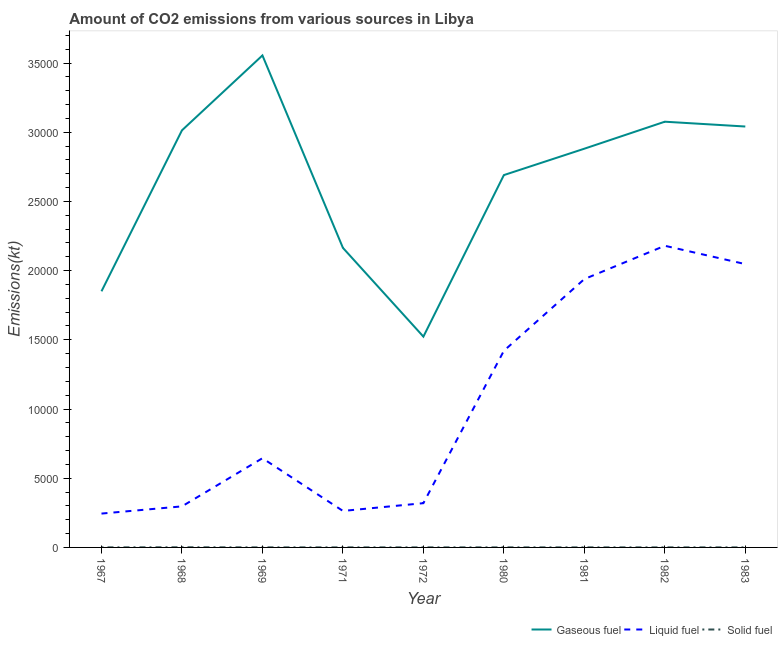How many different coloured lines are there?
Your answer should be compact. 3. Is the number of lines equal to the number of legend labels?
Keep it short and to the point. Yes. What is the amount of co2 emissions from solid fuel in 1967?
Your answer should be very brief. 3.67. Across all years, what is the maximum amount of co2 emissions from gaseous fuel?
Ensure brevity in your answer.  3.56e+04. Across all years, what is the minimum amount of co2 emissions from gaseous fuel?
Your response must be concise. 1.52e+04. In which year was the amount of co2 emissions from solid fuel maximum?
Give a very brief answer. 1968. In which year was the amount of co2 emissions from gaseous fuel minimum?
Offer a terse response. 1972. What is the total amount of co2 emissions from liquid fuel in the graph?
Your answer should be very brief. 9.36e+04. What is the difference between the amount of co2 emissions from solid fuel in 1969 and that in 1983?
Your answer should be compact. 0. What is the difference between the amount of co2 emissions from solid fuel in 1981 and the amount of co2 emissions from gaseous fuel in 1967?
Make the answer very short. -1.85e+04. What is the average amount of co2 emissions from solid fuel per year?
Give a very brief answer. 4.48. In the year 1983, what is the difference between the amount of co2 emissions from gaseous fuel and amount of co2 emissions from solid fuel?
Keep it short and to the point. 3.04e+04. What is the ratio of the amount of co2 emissions from liquid fuel in 1967 to that in 1968?
Your answer should be compact. 0.82. Is the amount of co2 emissions from gaseous fuel in 1968 less than that in 1971?
Your answer should be compact. No. Is the difference between the amount of co2 emissions from solid fuel in 1969 and 1980 greater than the difference between the amount of co2 emissions from liquid fuel in 1969 and 1980?
Keep it short and to the point. Yes. What is the difference between the highest and the second highest amount of co2 emissions from gaseous fuel?
Give a very brief answer. 4789.1. What is the difference between the highest and the lowest amount of co2 emissions from solid fuel?
Your answer should be compact. 7.33. In how many years, is the amount of co2 emissions from liquid fuel greater than the average amount of co2 emissions from liquid fuel taken over all years?
Your response must be concise. 4. Is the sum of the amount of co2 emissions from solid fuel in 1982 and 1983 greater than the maximum amount of co2 emissions from liquid fuel across all years?
Offer a very short reply. No. Is the amount of co2 emissions from gaseous fuel strictly less than the amount of co2 emissions from liquid fuel over the years?
Provide a short and direct response. No. How many years are there in the graph?
Your answer should be compact. 9. What is the difference between two consecutive major ticks on the Y-axis?
Offer a terse response. 5000. Are the values on the major ticks of Y-axis written in scientific E-notation?
Keep it short and to the point. No. Does the graph contain any zero values?
Your answer should be compact. No. Does the graph contain grids?
Make the answer very short. No. How many legend labels are there?
Offer a terse response. 3. What is the title of the graph?
Ensure brevity in your answer.  Amount of CO2 emissions from various sources in Libya. What is the label or title of the X-axis?
Your response must be concise. Year. What is the label or title of the Y-axis?
Your response must be concise. Emissions(kt). What is the Emissions(kt) of Gaseous fuel in 1967?
Offer a very short reply. 1.85e+04. What is the Emissions(kt) in Liquid fuel in 1967?
Provide a short and direct response. 2445.89. What is the Emissions(kt) in Solid fuel in 1967?
Give a very brief answer. 3.67. What is the Emissions(kt) of Gaseous fuel in 1968?
Keep it short and to the point. 3.01e+04. What is the Emissions(kt) in Liquid fuel in 1968?
Ensure brevity in your answer.  2966.6. What is the Emissions(kt) in Solid fuel in 1968?
Offer a terse response. 11. What is the Emissions(kt) of Gaseous fuel in 1969?
Provide a succinct answer. 3.56e+04. What is the Emissions(kt) in Liquid fuel in 1969?
Offer a terse response. 6446.59. What is the Emissions(kt) of Solid fuel in 1969?
Provide a succinct answer. 3.67. What is the Emissions(kt) in Gaseous fuel in 1971?
Your answer should be very brief. 2.16e+04. What is the Emissions(kt) in Liquid fuel in 1971?
Your answer should be very brief. 2636.57. What is the Emissions(kt) of Solid fuel in 1971?
Offer a terse response. 3.67. What is the Emissions(kt) of Gaseous fuel in 1972?
Make the answer very short. 1.52e+04. What is the Emissions(kt) in Liquid fuel in 1972?
Ensure brevity in your answer.  3197.62. What is the Emissions(kt) of Solid fuel in 1972?
Ensure brevity in your answer.  3.67. What is the Emissions(kt) of Gaseous fuel in 1980?
Ensure brevity in your answer.  2.69e+04. What is the Emissions(kt) of Liquid fuel in 1980?
Offer a terse response. 1.42e+04. What is the Emissions(kt) of Solid fuel in 1980?
Ensure brevity in your answer.  3.67. What is the Emissions(kt) in Gaseous fuel in 1981?
Provide a short and direct response. 2.88e+04. What is the Emissions(kt) in Liquid fuel in 1981?
Make the answer very short. 1.94e+04. What is the Emissions(kt) of Solid fuel in 1981?
Keep it short and to the point. 3.67. What is the Emissions(kt) in Gaseous fuel in 1982?
Offer a terse response. 3.08e+04. What is the Emissions(kt) in Liquid fuel in 1982?
Provide a succinct answer. 2.18e+04. What is the Emissions(kt) of Solid fuel in 1982?
Give a very brief answer. 3.67. What is the Emissions(kt) in Gaseous fuel in 1983?
Provide a succinct answer. 3.04e+04. What is the Emissions(kt) in Liquid fuel in 1983?
Offer a very short reply. 2.05e+04. What is the Emissions(kt) in Solid fuel in 1983?
Your answer should be compact. 3.67. Across all years, what is the maximum Emissions(kt) of Gaseous fuel?
Ensure brevity in your answer.  3.56e+04. Across all years, what is the maximum Emissions(kt) in Liquid fuel?
Provide a succinct answer. 2.18e+04. Across all years, what is the maximum Emissions(kt) of Solid fuel?
Your answer should be compact. 11. Across all years, what is the minimum Emissions(kt) of Gaseous fuel?
Keep it short and to the point. 1.52e+04. Across all years, what is the minimum Emissions(kt) of Liquid fuel?
Give a very brief answer. 2445.89. Across all years, what is the minimum Emissions(kt) in Solid fuel?
Your answer should be very brief. 3.67. What is the total Emissions(kt) of Gaseous fuel in the graph?
Give a very brief answer. 2.38e+05. What is the total Emissions(kt) in Liquid fuel in the graph?
Give a very brief answer. 9.36e+04. What is the total Emissions(kt) in Solid fuel in the graph?
Give a very brief answer. 40.34. What is the difference between the Emissions(kt) of Gaseous fuel in 1967 and that in 1968?
Your answer should be very brief. -1.16e+04. What is the difference between the Emissions(kt) of Liquid fuel in 1967 and that in 1968?
Offer a terse response. -520.71. What is the difference between the Emissions(kt) in Solid fuel in 1967 and that in 1968?
Ensure brevity in your answer.  -7.33. What is the difference between the Emissions(kt) of Gaseous fuel in 1967 and that in 1969?
Offer a very short reply. -1.70e+04. What is the difference between the Emissions(kt) in Liquid fuel in 1967 and that in 1969?
Give a very brief answer. -4000.7. What is the difference between the Emissions(kt) of Gaseous fuel in 1967 and that in 1971?
Your answer should be very brief. -3138.95. What is the difference between the Emissions(kt) of Liquid fuel in 1967 and that in 1971?
Give a very brief answer. -190.68. What is the difference between the Emissions(kt) of Gaseous fuel in 1967 and that in 1972?
Offer a terse response. 3274.63. What is the difference between the Emissions(kt) in Liquid fuel in 1967 and that in 1972?
Offer a terse response. -751.74. What is the difference between the Emissions(kt) in Solid fuel in 1967 and that in 1972?
Give a very brief answer. 0. What is the difference between the Emissions(kt) of Gaseous fuel in 1967 and that in 1980?
Give a very brief answer. -8397.43. What is the difference between the Emissions(kt) of Liquid fuel in 1967 and that in 1980?
Your answer should be compact. -1.18e+04. What is the difference between the Emissions(kt) in Gaseous fuel in 1967 and that in 1981?
Your answer should be compact. -1.03e+04. What is the difference between the Emissions(kt) of Liquid fuel in 1967 and that in 1981?
Provide a short and direct response. -1.69e+04. What is the difference between the Emissions(kt) of Gaseous fuel in 1967 and that in 1982?
Your answer should be compact. -1.23e+04. What is the difference between the Emissions(kt) in Liquid fuel in 1967 and that in 1982?
Make the answer very short. -1.94e+04. What is the difference between the Emissions(kt) of Solid fuel in 1967 and that in 1982?
Keep it short and to the point. 0. What is the difference between the Emissions(kt) in Gaseous fuel in 1967 and that in 1983?
Offer a very short reply. -1.19e+04. What is the difference between the Emissions(kt) in Liquid fuel in 1967 and that in 1983?
Your answer should be compact. -1.80e+04. What is the difference between the Emissions(kt) in Gaseous fuel in 1968 and that in 1969?
Your answer should be compact. -5412.49. What is the difference between the Emissions(kt) in Liquid fuel in 1968 and that in 1969?
Provide a short and direct response. -3479.98. What is the difference between the Emissions(kt) in Solid fuel in 1968 and that in 1969?
Ensure brevity in your answer.  7.33. What is the difference between the Emissions(kt) in Gaseous fuel in 1968 and that in 1971?
Your response must be concise. 8492.77. What is the difference between the Emissions(kt) of Liquid fuel in 1968 and that in 1971?
Provide a short and direct response. 330.03. What is the difference between the Emissions(kt) in Solid fuel in 1968 and that in 1971?
Ensure brevity in your answer.  7.33. What is the difference between the Emissions(kt) in Gaseous fuel in 1968 and that in 1972?
Provide a short and direct response. 1.49e+04. What is the difference between the Emissions(kt) in Liquid fuel in 1968 and that in 1972?
Your answer should be compact. -231.02. What is the difference between the Emissions(kt) in Solid fuel in 1968 and that in 1972?
Your answer should be very brief. 7.33. What is the difference between the Emissions(kt) of Gaseous fuel in 1968 and that in 1980?
Offer a very short reply. 3234.29. What is the difference between the Emissions(kt) in Liquid fuel in 1968 and that in 1980?
Keep it short and to the point. -1.12e+04. What is the difference between the Emissions(kt) in Solid fuel in 1968 and that in 1980?
Provide a succinct answer. 7.33. What is the difference between the Emissions(kt) in Gaseous fuel in 1968 and that in 1981?
Offer a terse response. 1327.45. What is the difference between the Emissions(kt) of Liquid fuel in 1968 and that in 1981?
Offer a terse response. -1.64e+04. What is the difference between the Emissions(kt) of Solid fuel in 1968 and that in 1981?
Give a very brief answer. 7.33. What is the difference between the Emissions(kt) in Gaseous fuel in 1968 and that in 1982?
Give a very brief answer. -623.39. What is the difference between the Emissions(kt) in Liquid fuel in 1968 and that in 1982?
Keep it short and to the point. -1.88e+04. What is the difference between the Emissions(kt) in Solid fuel in 1968 and that in 1982?
Your answer should be compact. 7.33. What is the difference between the Emissions(kt) of Gaseous fuel in 1968 and that in 1983?
Provide a short and direct response. -275.02. What is the difference between the Emissions(kt) of Liquid fuel in 1968 and that in 1983?
Provide a short and direct response. -1.75e+04. What is the difference between the Emissions(kt) in Solid fuel in 1968 and that in 1983?
Provide a succinct answer. 7.33. What is the difference between the Emissions(kt) of Gaseous fuel in 1969 and that in 1971?
Provide a succinct answer. 1.39e+04. What is the difference between the Emissions(kt) of Liquid fuel in 1969 and that in 1971?
Provide a succinct answer. 3810.01. What is the difference between the Emissions(kt) in Gaseous fuel in 1969 and that in 1972?
Provide a succinct answer. 2.03e+04. What is the difference between the Emissions(kt) of Liquid fuel in 1969 and that in 1972?
Keep it short and to the point. 3248.96. What is the difference between the Emissions(kt) in Gaseous fuel in 1969 and that in 1980?
Provide a succinct answer. 8646.79. What is the difference between the Emissions(kt) of Liquid fuel in 1969 and that in 1980?
Your answer should be very brief. -7763.04. What is the difference between the Emissions(kt) in Solid fuel in 1969 and that in 1980?
Keep it short and to the point. 0. What is the difference between the Emissions(kt) of Gaseous fuel in 1969 and that in 1981?
Provide a succinct answer. 6739.95. What is the difference between the Emissions(kt) in Liquid fuel in 1969 and that in 1981?
Provide a succinct answer. -1.29e+04. What is the difference between the Emissions(kt) in Solid fuel in 1969 and that in 1981?
Give a very brief answer. 0. What is the difference between the Emissions(kt) of Gaseous fuel in 1969 and that in 1982?
Your answer should be very brief. 4789.1. What is the difference between the Emissions(kt) in Liquid fuel in 1969 and that in 1982?
Your answer should be compact. -1.54e+04. What is the difference between the Emissions(kt) in Solid fuel in 1969 and that in 1982?
Your response must be concise. 0. What is the difference between the Emissions(kt) in Gaseous fuel in 1969 and that in 1983?
Make the answer very short. 5137.47. What is the difference between the Emissions(kt) in Liquid fuel in 1969 and that in 1983?
Your response must be concise. -1.40e+04. What is the difference between the Emissions(kt) of Gaseous fuel in 1971 and that in 1972?
Keep it short and to the point. 6413.58. What is the difference between the Emissions(kt) of Liquid fuel in 1971 and that in 1972?
Keep it short and to the point. -561.05. What is the difference between the Emissions(kt) in Solid fuel in 1971 and that in 1972?
Make the answer very short. 0. What is the difference between the Emissions(kt) of Gaseous fuel in 1971 and that in 1980?
Provide a succinct answer. -5258.48. What is the difference between the Emissions(kt) of Liquid fuel in 1971 and that in 1980?
Keep it short and to the point. -1.16e+04. What is the difference between the Emissions(kt) of Solid fuel in 1971 and that in 1980?
Offer a very short reply. 0. What is the difference between the Emissions(kt) of Gaseous fuel in 1971 and that in 1981?
Keep it short and to the point. -7165.32. What is the difference between the Emissions(kt) in Liquid fuel in 1971 and that in 1981?
Offer a very short reply. -1.68e+04. What is the difference between the Emissions(kt) in Solid fuel in 1971 and that in 1981?
Your answer should be very brief. 0. What is the difference between the Emissions(kt) in Gaseous fuel in 1971 and that in 1982?
Make the answer very short. -9116.16. What is the difference between the Emissions(kt) in Liquid fuel in 1971 and that in 1982?
Provide a short and direct response. -1.92e+04. What is the difference between the Emissions(kt) of Solid fuel in 1971 and that in 1982?
Your response must be concise. 0. What is the difference between the Emissions(kt) of Gaseous fuel in 1971 and that in 1983?
Your response must be concise. -8767.8. What is the difference between the Emissions(kt) of Liquid fuel in 1971 and that in 1983?
Offer a terse response. -1.78e+04. What is the difference between the Emissions(kt) of Gaseous fuel in 1972 and that in 1980?
Give a very brief answer. -1.17e+04. What is the difference between the Emissions(kt) of Liquid fuel in 1972 and that in 1980?
Your response must be concise. -1.10e+04. What is the difference between the Emissions(kt) of Solid fuel in 1972 and that in 1980?
Provide a short and direct response. 0. What is the difference between the Emissions(kt) in Gaseous fuel in 1972 and that in 1981?
Keep it short and to the point. -1.36e+04. What is the difference between the Emissions(kt) in Liquid fuel in 1972 and that in 1981?
Make the answer very short. -1.62e+04. What is the difference between the Emissions(kt) in Solid fuel in 1972 and that in 1981?
Ensure brevity in your answer.  0. What is the difference between the Emissions(kt) of Gaseous fuel in 1972 and that in 1982?
Offer a terse response. -1.55e+04. What is the difference between the Emissions(kt) in Liquid fuel in 1972 and that in 1982?
Provide a short and direct response. -1.86e+04. What is the difference between the Emissions(kt) of Gaseous fuel in 1972 and that in 1983?
Provide a succinct answer. -1.52e+04. What is the difference between the Emissions(kt) in Liquid fuel in 1972 and that in 1983?
Your response must be concise. -1.73e+04. What is the difference between the Emissions(kt) in Gaseous fuel in 1980 and that in 1981?
Keep it short and to the point. -1906.84. What is the difference between the Emissions(kt) in Liquid fuel in 1980 and that in 1981?
Offer a very short reply. -5181.47. What is the difference between the Emissions(kt) in Gaseous fuel in 1980 and that in 1982?
Your answer should be very brief. -3857.68. What is the difference between the Emissions(kt) of Liquid fuel in 1980 and that in 1982?
Provide a succinct answer. -7587.02. What is the difference between the Emissions(kt) of Solid fuel in 1980 and that in 1982?
Provide a succinct answer. 0. What is the difference between the Emissions(kt) of Gaseous fuel in 1980 and that in 1983?
Provide a succinct answer. -3509.32. What is the difference between the Emissions(kt) of Liquid fuel in 1980 and that in 1983?
Provide a short and direct response. -6263.24. What is the difference between the Emissions(kt) in Solid fuel in 1980 and that in 1983?
Provide a succinct answer. 0. What is the difference between the Emissions(kt) in Gaseous fuel in 1981 and that in 1982?
Your response must be concise. -1950.84. What is the difference between the Emissions(kt) in Liquid fuel in 1981 and that in 1982?
Make the answer very short. -2405.55. What is the difference between the Emissions(kt) of Gaseous fuel in 1981 and that in 1983?
Offer a very short reply. -1602.48. What is the difference between the Emissions(kt) in Liquid fuel in 1981 and that in 1983?
Offer a very short reply. -1081.77. What is the difference between the Emissions(kt) in Gaseous fuel in 1982 and that in 1983?
Keep it short and to the point. 348.37. What is the difference between the Emissions(kt) in Liquid fuel in 1982 and that in 1983?
Ensure brevity in your answer.  1323.79. What is the difference between the Emissions(kt) of Solid fuel in 1982 and that in 1983?
Ensure brevity in your answer.  0. What is the difference between the Emissions(kt) in Gaseous fuel in 1967 and the Emissions(kt) in Liquid fuel in 1968?
Your response must be concise. 1.55e+04. What is the difference between the Emissions(kt) in Gaseous fuel in 1967 and the Emissions(kt) in Solid fuel in 1968?
Offer a very short reply. 1.85e+04. What is the difference between the Emissions(kt) in Liquid fuel in 1967 and the Emissions(kt) in Solid fuel in 1968?
Give a very brief answer. 2434.89. What is the difference between the Emissions(kt) in Gaseous fuel in 1967 and the Emissions(kt) in Liquid fuel in 1969?
Give a very brief answer. 1.21e+04. What is the difference between the Emissions(kt) in Gaseous fuel in 1967 and the Emissions(kt) in Solid fuel in 1969?
Offer a very short reply. 1.85e+04. What is the difference between the Emissions(kt) in Liquid fuel in 1967 and the Emissions(kt) in Solid fuel in 1969?
Your answer should be compact. 2442.22. What is the difference between the Emissions(kt) in Gaseous fuel in 1967 and the Emissions(kt) in Liquid fuel in 1971?
Give a very brief answer. 1.59e+04. What is the difference between the Emissions(kt) of Gaseous fuel in 1967 and the Emissions(kt) of Solid fuel in 1971?
Your answer should be very brief. 1.85e+04. What is the difference between the Emissions(kt) in Liquid fuel in 1967 and the Emissions(kt) in Solid fuel in 1971?
Give a very brief answer. 2442.22. What is the difference between the Emissions(kt) in Gaseous fuel in 1967 and the Emissions(kt) in Liquid fuel in 1972?
Offer a very short reply. 1.53e+04. What is the difference between the Emissions(kt) in Gaseous fuel in 1967 and the Emissions(kt) in Solid fuel in 1972?
Your answer should be compact. 1.85e+04. What is the difference between the Emissions(kt) of Liquid fuel in 1967 and the Emissions(kt) of Solid fuel in 1972?
Offer a terse response. 2442.22. What is the difference between the Emissions(kt) of Gaseous fuel in 1967 and the Emissions(kt) of Liquid fuel in 1980?
Your answer should be very brief. 4297.72. What is the difference between the Emissions(kt) in Gaseous fuel in 1967 and the Emissions(kt) in Solid fuel in 1980?
Give a very brief answer. 1.85e+04. What is the difference between the Emissions(kt) in Liquid fuel in 1967 and the Emissions(kt) in Solid fuel in 1980?
Provide a short and direct response. 2442.22. What is the difference between the Emissions(kt) of Gaseous fuel in 1967 and the Emissions(kt) of Liquid fuel in 1981?
Your answer should be very brief. -883.75. What is the difference between the Emissions(kt) in Gaseous fuel in 1967 and the Emissions(kt) in Solid fuel in 1981?
Provide a succinct answer. 1.85e+04. What is the difference between the Emissions(kt) in Liquid fuel in 1967 and the Emissions(kt) in Solid fuel in 1981?
Your answer should be compact. 2442.22. What is the difference between the Emissions(kt) in Gaseous fuel in 1967 and the Emissions(kt) in Liquid fuel in 1982?
Ensure brevity in your answer.  -3289.3. What is the difference between the Emissions(kt) of Gaseous fuel in 1967 and the Emissions(kt) of Solid fuel in 1982?
Provide a succinct answer. 1.85e+04. What is the difference between the Emissions(kt) in Liquid fuel in 1967 and the Emissions(kt) in Solid fuel in 1982?
Your answer should be compact. 2442.22. What is the difference between the Emissions(kt) in Gaseous fuel in 1967 and the Emissions(kt) in Liquid fuel in 1983?
Make the answer very short. -1965.51. What is the difference between the Emissions(kt) of Gaseous fuel in 1967 and the Emissions(kt) of Solid fuel in 1983?
Ensure brevity in your answer.  1.85e+04. What is the difference between the Emissions(kt) of Liquid fuel in 1967 and the Emissions(kt) of Solid fuel in 1983?
Make the answer very short. 2442.22. What is the difference between the Emissions(kt) in Gaseous fuel in 1968 and the Emissions(kt) in Liquid fuel in 1969?
Your answer should be very brief. 2.37e+04. What is the difference between the Emissions(kt) of Gaseous fuel in 1968 and the Emissions(kt) of Solid fuel in 1969?
Make the answer very short. 3.01e+04. What is the difference between the Emissions(kt) of Liquid fuel in 1968 and the Emissions(kt) of Solid fuel in 1969?
Give a very brief answer. 2962.94. What is the difference between the Emissions(kt) of Gaseous fuel in 1968 and the Emissions(kt) of Liquid fuel in 1971?
Offer a terse response. 2.75e+04. What is the difference between the Emissions(kt) in Gaseous fuel in 1968 and the Emissions(kt) in Solid fuel in 1971?
Provide a short and direct response. 3.01e+04. What is the difference between the Emissions(kt) in Liquid fuel in 1968 and the Emissions(kt) in Solid fuel in 1971?
Provide a short and direct response. 2962.94. What is the difference between the Emissions(kt) of Gaseous fuel in 1968 and the Emissions(kt) of Liquid fuel in 1972?
Your answer should be compact. 2.69e+04. What is the difference between the Emissions(kt) of Gaseous fuel in 1968 and the Emissions(kt) of Solid fuel in 1972?
Offer a terse response. 3.01e+04. What is the difference between the Emissions(kt) of Liquid fuel in 1968 and the Emissions(kt) of Solid fuel in 1972?
Your answer should be compact. 2962.94. What is the difference between the Emissions(kt) of Gaseous fuel in 1968 and the Emissions(kt) of Liquid fuel in 1980?
Keep it short and to the point. 1.59e+04. What is the difference between the Emissions(kt) in Gaseous fuel in 1968 and the Emissions(kt) in Solid fuel in 1980?
Your answer should be very brief. 3.01e+04. What is the difference between the Emissions(kt) in Liquid fuel in 1968 and the Emissions(kt) in Solid fuel in 1980?
Your response must be concise. 2962.94. What is the difference between the Emissions(kt) of Gaseous fuel in 1968 and the Emissions(kt) of Liquid fuel in 1981?
Ensure brevity in your answer.  1.07e+04. What is the difference between the Emissions(kt) in Gaseous fuel in 1968 and the Emissions(kt) in Solid fuel in 1981?
Offer a very short reply. 3.01e+04. What is the difference between the Emissions(kt) in Liquid fuel in 1968 and the Emissions(kt) in Solid fuel in 1981?
Keep it short and to the point. 2962.94. What is the difference between the Emissions(kt) of Gaseous fuel in 1968 and the Emissions(kt) of Liquid fuel in 1982?
Keep it short and to the point. 8342.42. What is the difference between the Emissions(kt) of Gaseous fuel in 1968 and the Emissions(kt) of Solid fuel in 1982?
Provide a short and direct response. 3.01e+04. What is the difference between the Emissions(kt) of Liquid fuel in 1968 and the Emissions(kt) of Solid fuel in 1982?
Give a very brief answer. 2962.94. What is the difference between the Emissions(kt) of Gaseous fuel in 1968 and the Emissions(kt) of Liquid fuel in 1983?
Your response must be concise. 9666.21. What is the difference between the Emissions(kt) in Gaseous fuel in 1968 and the Emissions(kt) in Solid fuel in 1983?
Provide a succinct answer. 3.01e+04. What is the difference between the Emissions(kt) of Liquid fuel in 1968 and the Emissions(kt) of Solid fuel in 1983?
Ensure brevity in your answer.  2962.94. What is the difference between the Emissions(kt) of Gaseous fuel in 1969 and the Emissions(kt) of Liquid fuel in 1971?
Offer a terse response. 3.29e+04. What is the difference between the Emissions(kt) of Gaseous fuel in 1969 and the Emissions(kt) of Solid fuel in 1971?
Give a very brief answer. 3.55e+04. What is the difference between the Emissions(kt) of Liquid fuel in 1969 and the Emissions(kt) of Solid fuel in 1971?
Your answer should be compact. 6442.92. What is the difference between the Emissions(kt) in Gaseous fuel in 1969 and the Emissions(kt) in Liquid fuel in 1972?
Your answer should be compact. 3.24e+04. What is the difference between the Emissions(kt) in Gaseous fuel in 1969 and the Emissions(kt) in Solid fuel in 1972?
Provide a succinct answer. 3.55e+04. What is the difference between the Emissions(kt) in Liquid fuel in 1969 and the Emissions(kt) in Solid fuel in 1972?
Provide a short and direct response. 6442.92. What is the difference between the Emissions(kt) in Gaseous fuel in 1969 and the Emissions(kt) in Liquid fuel in 1980?
Offer a terse response. 2.13e+04. What is the difference between the Emissions(kt) of Gaseous fuel in 1969 and the Emissions(kt) of Solid fuel in 1980?
Provide a succinct answer. 3.55e+04. What is the difference between the Emissions(kt) in Liquid fuel in 1969 and the Emissions(kt) in Solid fuel in 1980?
Offer a terse response. 6442.92. What is the difference between the Emissions(kt) in Gaseous fuel in 1969 and the Emissions(kt) in Liquid fuel in 1981?
Your response must be concise. 1.62e+04. What is the difference between the Emissions(kt) of Gaseous fuel in 1969 and the Emissions(kt) of Solid fuel in 1981?
Provide a succinct answer. 3.55e+04. What is the difference between the Emissions(kt) of Liquid fuel in 1969 and the Emissions(kt) of Solid fuel in 1981?
Make the answer very short. 6442.92. What is the difference between the Emissions(kt) of Gaseous fuel in 1969 and the Emissions(kt) of Liquid fuel in 1982?
Offer a very short reply. 1.38e+04. What is the difference between the Emissions(kt) in Gaseous fuel in 1969 and the Emissions(kt) in Solid fuel in 1982?
Your answer should be compact. 3.55e+04. What is the difference between the Emissions(kt) of Liquid fuel in 1969 and the Emissions(kt) of Solid fuel in 1982?
Your answer should be very brief. 6442.92. What is the difference between the Emissions(kt) of Gaseous fuel in 1969 and the Emissions(kt) of Liquid fuel in 1983?
Offer a terse response. 1.51e+04. What is the difference between the Emissions(kt) in Gaseous fuel in 1969 and the Emissions(kt) in Solid fuel in 1983?
Provide a succinct answer. 3.55e+04. What is the difference between the Emissions(kt) in Liquid fuel in 1969 and the Emissions(kt) in Solid fuel in 1983?
Give a very brief answer. 6442.92. What is the difference between the Emissions(kt) in Gaseous fuel in 1971 and the Emissions(kt) in Liquid fuel in 1972?
Your answer should be compact. 1.84e+04. What is the difference between the Emissions(kt) in Gaseous fuel in 1971 and the Emissions(kt) in Solid fuel in 1972?
Offer a terse response. 2.16e+04. What is the difference between the Emissions(kt) in Liquid fuel in 1971 and the Emissions(kt) in Solid fuel in 1972?
Your response must be concise. 2632.91. What is the difference between the Emissions(kt) in Gaseous fuel in 1971 and the Emissions(kt) in Liquid fuel in 1980?
Your response must be concise. 7436.68. What is the difference between the Emissions(kt) in Gaseous fuel in 1971 and the Emissions(kt) in Solid fuel in 1980?
Ensure brevity in your answer.  2.16e+04. What is the difference between the Emissions(kt) of Liquid fuel in 1971 and the Emissions(kt) of Solid fuel in 1980?
Keep it short and to the point. 2632.91. What is the difference between the Emissions(kt) in Gaseous fuel in 1971 and the Emissions(kt) in Liquid fuel in 1981?
Give a very brief answer. 2255.2. What is the difference between the Emissions(kt) of Gaseous fuel in 1971 and the Emissions(kt) of Solid fuel in 1981?
Your response must be concise. 2.16e+04. What is the difference between the Emissions(kt) in Liquid fuel in 1971 and the Emissions(kt) in Solid fuel in 1981?
Your response must be concise. 2632.91. What is the difference between the Emissions(kt) in Gaseous fuel in 1971 and the Emissions(kt) in Liquid fuel in 1982?
Provide a short and direct response. -150.35. What is the difference between the Emissions(kt) of Gaseous fuel in 1971 and the Emissions(kt) of Solid fuel in 1982?
Your answer should be compact. 2.16e+04. What is the difference between the Emissions(kt) in Liquid fuel in 1971 and the Emissions(kt) in Solid fuel in 1982?
Your answer should be compact. 2632.91. What is the difference between the Emissions(kt) in Gaseous fuel in 1971 and the Emissions(kt) in Liquid fuel in 1983?
Your response must be concise. 1173.44. What is the difference between the Emissions(kt) in Gaseous fuel in 1971 and the Emissions(kt) in Solid fuel in 1983?
Ensure brevity in your answer.  2.16e+04. What is the difference between the Emissions(kt) of Liquid fuel in 1971 and the Emissions(kt) of Solid fuel in 1983?
Your answer should be very brief. 2632.91. What is the difference between the Emissions(kt) in Gaseous fuel in 1972 and the Emissions(kt) in Liquid fuel in 1980?
Give a very brief answer. 1023.09. What is the difference between the Emissions(kt) in Gaseous fuel in 1972 and the Emissions(kt) in Solid fuel in 1980?
Offer a terse response. 1.52e+04. What is the difference between the Emissions(kt) in Liquid fuel in 1972 and the Emissions(kt) in Solid fuel in 1980?
Ensure brevity in your answer.  3193.96. What is the difference between the Emissions(kt) in Gaseous fuel in 1972 and the Emissions(kt) in Liquid fuel in 1981?
Keep it short and to the point. -4158.38. What is the difference between the Emissions(kt) in Gaseous fuel in 1972 and the Emissions(kt) in Solid fuel in 1981?
Make the answer very short. 1.52e+04. What is the difference between the Emissions(kt) in Liquid fuel in 1972 and the Emissions(kt) in Solid fuel in 1981?
Make the answer very short. 3193.96. What is the difference between the Emissions(kt) of Gaseous fuel in 1972 and the Emissions(kt) of Liquid fuel in 1982?
Provide a succinct answer. -6563.93. What is the difference between the Emissions(kt) of Gaseous fuel in 1972 and the Emissions(kt) of Solid fuel in 1982?
Your response must be concise. 1.52e+04. What is the difference between the Emissions(kt) of Liquid fuel in 1972 and the Emissions(kt) of Solid fuel in 1982?
Provide a succinct answer. 3193.96. What is the difference between the Emissions(kt) of Gaseous fuel in 1972 and the Emissions(kt) of Liquid fuel in 1983?
Provide a short and direct response. -5240.14. What is the difference between the Emissions(kt) of Gaseous fuel in 1972 and the Emissions(kt) of Solid fuel in 1983?
Provide a short and direct response. 1.52e+04. What is the difference between the Emissions(kt) in Liquid fuel in 1972 and the Emissions(kt) in Solid fuel in 1983?
Your answer should be very brief. 3193.96. What is the difference between the Emissions(kt) in Gaseous fuel in 1980 and the Emissions(kt) in Liquid fuel in 1981?
Ensure brevity in your answer.  7513.68. What is the difference between the Emissions(kt) in Gaseous fuel in 1980 and the Emissions(kt) in Solid fuel in 1981?
Give a very brief answer. 2.69e+04. What is the difference between the Emissions(kt) of Liquid fuel in 1980 and the Emissions(kt) of Solid fuel in 1981?
Provide a succinct answer. 1.42e+04. What is the difference between the Emissions(kt) in Gaseous fuel in 1980 and the Emissions(kt) in Liquid fuel in 1982?
Provide a succinct answer. 5108.13. What is the difference between the Emissions(kt) in Gaseous fuel in 1980 and the Emissions(kt) in Solid fuel in 1982?
Keep it short and to the point. 2.69e+04. What is the difference between the Emissions(kt) in Liquid fuel in 1980 and the Emissions(kt) in Solid fuel in 1982?
Your response must be concise. 1.42e+04. What is the difference between the Emissions(kt) in Gaseous fuel in 1980 and the Emissions(kt) in Liquid fuel in 1983?
Give a very brief answer. 6431.92. What is the difference between the Emissions(kt) in Gaseous fuel in 1980 and the Emissions(kt) in Solid fuel in 1983?
Offer a very short reply. 2.69e+04. What is the difference between the Emissions(kt) in Liquid fuel in 1980 and the Emissions(kt) in Solid fuel in 1983?
Ensure brevity in your answer.  1.42e+04. What is the difference between the Emissions(kt) of Gaseous fuel in 1981 and the Emissions(kt) of Liquid fuel in 1982?
Provide a succinct answer. 7014.97. What is the difference between the Emissions(kt) of Gaseous fuel in 1981 and the Emissions(kt) of Solid fuel in 1982?
Ensure brevity in your answer.  2.88e+04. What is the difference between the Emissions(kt) of Liquid fuel in 1981 and the Emissions(kt) of Solid fuel in 1982?
Your answer should be compact. 1.94e+04. What is the difference between the Emissions(kt) of Gaseous fuel in 1981 and the Emissions(kt) of Liquid fuel in 1983?
Make the answer very short. 8338.76. What is the difference between the Emissions(kt) in Gaseous fuel in 1981 and the Emissions(kt) in Solid fuel in 1983?
Offer a terse response. 2.88e+04. What is the difference between the Emissions(kt) of Liquid fuel in 1981 and the Emissions(kt) of Solid fuel in 1983?
Offer a terse response. 1.94e+04. What is the difference between the Emissions(kt) of Gaseous fuel in 1982 and the Emissions(kt) of Liquid fuel in 1983?
Your answer should be compact. 1.03e+04. What is the difference between the Emissions(kt) in Gaseous fuel in 1982 and the Emissions(kt) in Solid fuel in 1983?
Your response must be concise. 3.08e+04. What is the difference between the Emissions(kt) of Liquid fuel in 1982 and the Emissions(kt) of Solid fuel in 1983?
Your response must be concise. 2.18e+04. What is the average Emissions(kt) of Gaseous fuel per year?
Make the answer very short. 2.64e+04. What is the average Emissions(kt) of Liquid fuel per year?
Offer a terse response. 1.04e+04. What is the average Emissions(kt) in Solid fuel per year?
Offer a very short reply. 4.48. In the year 1967, what is the difference between the Emissions(kt) of Gaseous fuel and Emissions(kt) of Liquid fuel?
Offer a very short reply. 1.61e+04. In the year 1967, what is the difference between the Emissions(kt) in Gaseous fuel and Emissions(kt) in Solid fuel?
Your response must be concise. 1.85e+04. In the year 1967, what is the difference between the Emissions(kt) of Liquid fuel and Emissions(kt) of Solid fuel?
Provide a succinct answer. 2442.22. In the year 1968, what is the difference between the Emissions(kt) in Gaseous fuel and Emissions(kt) in Liquid fuel?
Your answer should be very brief. 2.72e+04. In the year 1968, what is the difference between the Emissions(kt) of Gaseous fuel and Emissions(kt) of Solid fuel?
Your response must be concise. 3.01e+04. In the year 1968, what is the difference between the Emissions(kt) of Liquid fuel and Emissions(kt) of Solid fuel?
Provide a short and direct response. 2955.6. In the year 1969, what is the difference between the Emissions(kt) in Gaseous fuel and Emissions(kt) in Liquid fuel?
Offer a very short reply. 2.91e+04. In the year 1969, what is the difference between the Emissions(kt) of Gaseous fuel and Emissions(kt) of Solid fuel?
Ensure brevity in your answer.  3.55e+04. In the year 1969, what is the difference between the Emissions(kt) in Liquid fuel and Emissions(kt) in Solid fuel?
Ensure brevity in your answer.  6442.92. In the year 1971, what is the difference between the Emissions(kt) in Gaseous fuel and Emissions(kt) in Liquid fuel?
Provide a succinct answer. 1.90e+04. In the year 1971, what is the difference between the Emissions(kt) of Gaseous fuel and Emissions(kt) of Solid fuel?
Give a very brief answer. 2.16e+04. In the year 1971, what is the difference between the Emissions(kt) of Liquid fuel and Emissions(kt) of Solid fuel?
Make the answer very short. 2632.91. In the year 1972, what is the difference between the Emissions(kt) of Gaseous fuel and Emissions(kt) of Liquid fuel?
Provide a short and direct response. 1.20e+04. In the year 1972, what is the difference between the Emissions(kt) of Gaseous fuel and Emissions(kt) of Solid fuel?
Offer a very short reply. 1.52e+04. In the year 1972, what is the difference between the Emissions(kt) of Liquid fuel and Emissions(kt) of Solid fuel?
Ensure brevity in your answer.  3193.96. In the year 1980, what is the difference between the Emissions(kt) in Gaseous fuel and Emissions(kt) in Liquid fuel?
Your answer should be very brief. 1.27e+04. In the year 1980, what is the difference between the Emissions(kt) in Gaseous fuel and Emissions(kt) in Solid fuel?
Provide a succinct answer. 2.69e+04. In the year 1980, what is the difference between the Emissions(kt) in Liquid fuel and Emissions(kt) in Solid fuel?
Offer a terse response. 1.42e+04. In the year 1981, what is the difference between the Emissions(kt) of Gaseous fuel and Emissions(kt) of Liquid fuel?
Offer a very short reply. 9420.52. In the year 1981, what is the difference between the Emissions(kt) in Gaseous fuel and Emissions(kt) in Solid fuel?
Your answer should be compact. 2.88e+04. In the year 1981, what is the difference between the Emissions(kt) of Liquid fuel and Emissions(kt) of Solid fuel?
Offer a very short reply. 1.94e+04. In the year 1982, what is the difference between the Emissions(kt) of Gaseous fuel and Emissions(kt) of Liquid fuel?
Make the answer very short. 8965.82. In the year 1982, what is the difference between the Emissions(kt) in Gaseous fuel and Emissions(kt) in Solid fuel?
Offer a terse response. 3.08e+04. In the year 1982, what is the difference between the Emissions(kt) of Liquid fuel and Emissions(kt) of Solid fuel?
Give a very brief answer. 2.18e+04. In the year 1983, what is the difference between the Emissions(kt) of Gaseous fuel and Emissions(kt) of Liquid fuel?
Provide a short and direct response. 9941.24. In the year 1983, what is the difference between the Emissions(kt) of Gaseous fuel and Emissions(kt) of Solid fuel?
Keep it short and to the point. 3.04e+04. In the year 1983, what is the difference between the Emissions(kt) of Liquid fuel and Emissions(kt) of Solid fuel?
Make the answer very short. 2.05e+04. What is the ratio of the Emissions(kt) in Gaseous fuel in 1967 to that in 1968?
Ensure brevity in your answer.  0.61. What is the ratio of the Emissions(kt) of Liquid fuel in 1967 to that in 1968?
Your answer should be very brief. 0.82. What is the ratio of the Emissions(kt) of Gaseous fuel in 1967 to that in 1969?
Provide a short and direct response. 0.52. What is the ratio of the Emissions(kt) of Liquid fuel in 1967 to that in 1969?
Keep it short and to the point. 0.38. What is the ratio of the Emissions(kt) of Solid fuel in 1967 to that in 1969?
Offer a terse response. 1. What is the ratio of the Emissions(kt) of Gaseous fuel in 1967 to that in 1971?
Your answer should be very brief. 0.85. What is the ratio of the Emissions(kt) in Liquid fuel in 1967 to that in 1971?
Ensure brevity in your answer.  0.93. What is the ratio of the Emissions(kt) in Solid fuel in 1967 to that in 1971?
Provide a short and direct response. 1. What is the ratio of the Emissions(kt) in Gaseous fuel in 1967 to that in 1972?
Provide a succinct answer. 1.22. What is the ratio of the Emissions(kt) in Liquid fuel in 1967 to that in 1972?
Keep it short and to the point. 0.76. What is the ratio of the Emissions(kt) of Solid fuel in 1967 to that in 1972?
Make the answer very short. 1. What is the ratio of the Emissions(kt) in Gaseous fuel in 1967 to that in 1980?
Offer a terse response. 0.69. What is the ratio of the Emissions(kt) in Liquid fuel in 1967 to that in 1980?
Provide a succinct answer. 0.17. What is the ratio of the Emissions(kt) in Gaseous fuel in 1967 to that in 1981?
Make the answer very short. 0.64. What is the ratio of the Emissions(kt) in Liquid fuel in 1967 to that in 1981?
Provide a succinct answer. 0.13. What is the ratio of the Emissions(kt) of Gaseous fuel in 1967 to that in 1982?
Your answer should be very brief. 0.6. What is the ratio of the Emissions(kt) in Liquid fuel in 1967 to that in 1982?
Give a very brief answer. 0.11. What is the ratio of the Emissions(kt) in Gaseous fuel in 1967 to that in 1983?
Keep it short and to the point. 0.61. What is the ratio of the Emissions(kt) in Liquid fuel in 1967 to that in 1983?
Make the answer very short. 0.12. What is the ratio of the Emissions(kt) of Gaseous fuel in 1968 to that in 1969?
Your response must be concise. 0.85. What is the ratio of the Emissions(kt) of Liquid fuel in 1968 to that in 1969?
Offer a terse response. 0.46. What is the ratio of the Emissions(kt) in Gaseous fuel in 1968 to that in 1971?
Provide a short and direct response. 1.39. What is the ratio of the Emissions(kt) of Liquid fuel in 1968 to that in 1971?
Your answer should be compact. 1.13. What is the ratio of the Emissions(kt) of Gaseous fuel in 1968 to that in 1972?
Ensure brevity in your answer.  1.98. What is the ratio of the Emissions(kt) of Liquid fuel in 1968 to that in 1972?
Offer a terse response. 0.93. What is the ratio of the Emissions(kt) of Solid fuel in 1968 to that in 1972?
Provide a succinct answer. 3. What is the ratio of the Emissions(kt) in Gaseous fuel in 1968 to that in 1980?
Your answer should be very brief. 1.12. What is the ratio of the Emissions(kt) in Liquid fuel in 1968 to that in 1980?
Ensure brevity in your answer.  0.21. What is the ratio of the Emissions(kt) of Solid fuel in 1968 to that in 1980?
Make the answer very short. 3. What is the ratio of the Emissions(kt) of Gaseous fuel in 1968 to that in 1981?
Ensure brevity in your answer.  1.05. What is the ratio of the Emissions(kt) of Liquid fuel in 1968 to that in 1981?
Your response must be concise. 0.15. What is the ratio of the Emissions(kt) in Solid fuel in 1968 to that in 1981?
Your answer should be very brief. 3. What is the ratio of the Emissions(kt) of Gaseous fuel in 1968 to that in 1982?
Your response must be concise. 0.98. What is the ratio of the Emissions(kt) of Liquid fuel in 1968 to that in 1982?
Provide a short and direct response. 0.14. What is the ratio of the Emissions(kt) of Solid fuel in 1968 to that in 1982?
Your response must be concise. 3. What is the ratio of the Emissions(kt) in Liquid fuel in 1968 to that in 1983?
Your answer should be very brief. 0.14. What is the ratio of the Emissions(kt) of Gaseous fuel in 1969 to that in 1971?
Provide a succinct answer. 1.64. What is the ratio of the Emissions(kt) in Liquid fuel in 1969 to that in 1971?
Ensure brevity in your answer.  2.45. What is the ratio of the Emissions(kt) in Gaseous fuel in 1969 to that in 1972?
Make the answer very short. 2.33. What is the ratio of the Emissions(kt) in Liquid fuel in 1969 to that in 1972?
Provide a short and direct response. 2.02. What is the ratio of the Emissions(kt) of Gaseous fuel in 1969 to that in 1980?
Make the answer very short. 1.32. What is the ratio of the Emissions(kt) of Liquid fuel in 1969 to that in 1980?
Your answer should be very brief. 0.45. What is the ratio of the Emissions(kt) in Gaseous fuel in 1969 to that in 1981?
Your answer should be compact. 1.23. What is the ratio of the Emissions(kt) in Liquid fuel in 1969 to that in 1981?
Provide a succinct answer. 0.33. What is the ratio of the Emissions(kt) of Gaseous fuel in 1969 to that in 1982?
Give a very brief answer. 1.16. What is the ratio of the Emissions(kt) in Liquid fuel in 1969 to that in 1982?
Make the answer very short. 0.3. What is the ratio of the Emissions(kt) of Solid fuel in 1969 to that in 1982?
Your response must be concise. 1. What is the ratio of the Emissions(kt) in Gaseous fuel in 1969 to that in 1983?
Your answer should be very brief. 1.17. What is the ratio of the Emissions(kt) of Liquid fuel in 1969 to that in 1983?
Make the answer very short. 0.31. What is the ratio of the Emissions(kt) of Solid fuel in 1969 to that in 1983?
Provide a short and direct response. 1. What is the ratio of the Emissions(kt) of Gaseous fuel in 1971 to that in 1972?
Make the answer very short. 1.42. What is the ratio of the Emissions(kt) in Liquid fuel in 1971 to that in 1972?
Your response must be concise. 0.82. What is the ratio of the Emissions(kt) of Solid fuel in 1971 to that in 1972?
Offer a very short reply. 1. What is the ratio of the Emissions(kt) of Gaseous fuel in 1971 to that in 1980?
Give a very brief answer. 0.8. What is the ratio of the Emissions(kt) in Liquid fuel in 1971 to that in 1980?
Offer a terse response. 0.19. What is the ratio of the Emissions(kt) in Gaseous fuel in 1971 to that in 1981?
Provide a succinct answer. 0.75. What is the ratio of the Emissions(kt) in Liquid fuel in 1971 to that in 1981?
Ensure brevity in your answer.  0.14. What is the ratio of the Emissions(kt) of Solid fuel in 1971 to that in 1981?
Provide a short and direct response. 1. What is the ratio of the Emissions(kt) of Gaseous fuel in 1971 to that in 1982?
Provide a succinct answer. 0.7. What is the ratio of the Emissions(kt) in Liquid fuel in 1971 to that in 1982?
Provide a succinct answer. 0.12. What is the ratio of the Emissions(kt) in Gaseous fuel in 1971 to that in 1983?
Your answer should be compact. 0.71. What is the ratio of the Emissions(kt) in Liquid fuel in 1971 to that in 1983?
Make the answer very short. 0.13. What is the ratio of the Emissions(kt) of Gaseous fuel in 1972 to that in 1980?
Your response must be concise. 0.57. What is the ratio of the Emissions(kt) in Liquid fuel in 1972 to that in 1980?
Give a very brief answer. 0.23. What is the ratio of the Emissions(kt) in Solid fuel in 1972 to that in 1980?
Offer a terse response. 1. What is the ratio of the Emissions(kt) of Gaseous fuel in 1972 to that in 1981?
Offer a very short reply. 0.53. What is the ratio of the Emissions(kt) in Liquid fuel in 1972 to that in 1981?
Offer a very short reply. 0.16. What is the ratio of the Emissions(kt) in Gaseous fuel in 1972 to that in 1982?
Offer a terse response. 0.5. What is the ratio of the Emissions(kt) in Liquid fuel in 1972 to that in 1982?
Your answer should be compact. 0.15. What is the ratio of the Emissions(kt) of Gaseous fuel in 1972 to that in 1983?
Make the answer very short. 0.5. What is the ratio of the Emissions(kt) of Liquid fuel in 1972 to that in 1983?
Your answer should be compact. 0.16. What is the ratio of the Emissions(kt) in Gaseous fuel in 1980 to that in 1981?
Provide a short and direct response. 0.93. What is the ratio of the Emissions(kt) in Liquid fuel in 1980 to that in 1981?
Keep it short and to the point. 0.73. What is the ratio of the Emissions(kt) of Gaseous fuel in 1980 to that in 1982?
Offer a terse response. 0.87. What is the ratio of the Emissions(kt) in Liquid fuel in 1980 to that in 1982?
Provide a succinct answer. 0.65. What is the ratio of the Emissions(kt) of Gaseous fuel in 1980 to that in 1983?
Offer a very short reply. 0.88. What is the ratio of the Emissions(kt) of Liquid fuel in 1980 to that in 1983?
Your answer should be compact. 0.69. What is the ratio of the Emissions(kt) in Gaseous fuel in 1981 to that in 1982?
Provide a succinct answer. 0.94. What is the ratio of the Emissions(kt) in Liquid fuel in 1981 to that in 1982?
Your answer should be compact. 0.89. What is the ratio of the Emissions(kt) of Solid fuel in 1981 to that in 1982?
Offer a very short reply. 1. What is the ratio of the Emissions(kt) of Gaseous fuel in 1981 to that in 1983?
Your answer should be compact. 0.95. What is the ratio of the Emissions(kt) of Liquid fuel in 1981 to that in 1983?
Your response must be concise. 0.95. What is the ratio of the Emissions(kt) of Solid fuel in 1981 to that in 1983?
Offer a terse response. 1. What is the ratio of the Emissions(kt) of Gaseous fuel in 1982 to that in 1983?
Keep it short and to the point. 1.01. What is the ratio of the Emissions(kt) of Liquid fuel in 1982 to that in 1983?
Provide a succinct answer. 1.06. What is the ratio of the Emissions(kt) in Solid fuel in 1982 to that in 1983?
Offer a terse response. 1. What is the difference between the highest and the second highest Emissions(kt) of Gaseous fuel?
Your answer should be compact. 4789.1. What is the difference between the highest and the second highest Emissions(kt) in Liquid fuel?
Your response must be concise. 1323.79. What is the difference between the highest and the second highest Emissions(kt) in Solid fuel?
Offer a terse response. 7.33. What is the difference between the highest and the lowest Emissions(kt) of Gaseous fuel?
Provide a short and direct response. 2.03e+04. What is the difference between the highest and the lowest Emissions(kt) in Liquid fuel?
Your answer should be very brief. 1.94e+04. What is the difference between the highest and the lowest Emissions(kt) in Solid fuel?
Your answer should be very brief. 7.33. 